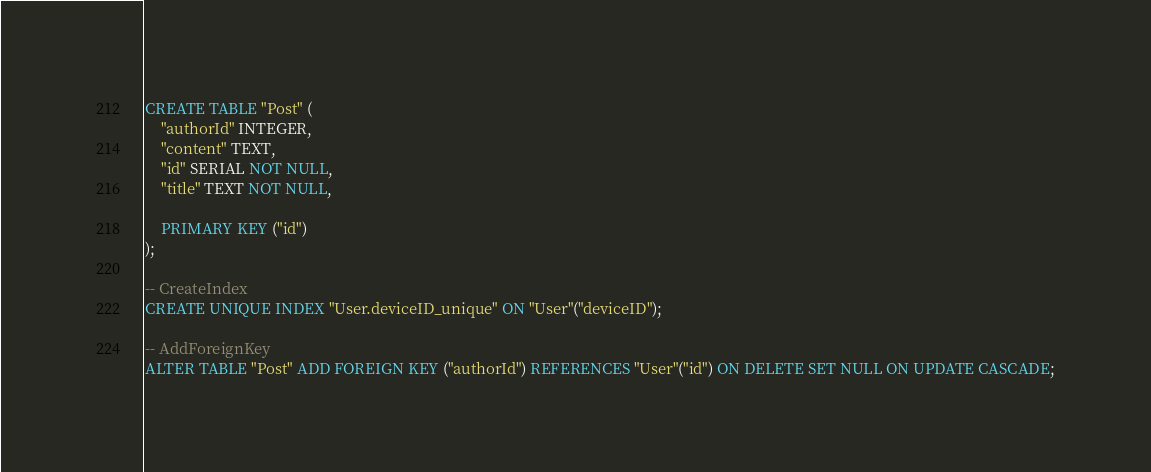<code> <loc_0><loc_0><loc_500><loc_500><_SQL_>CREATE TABLE "Post" (
    "authorId" INTEGER,
    "content" TEXT,
    "id" SERIAL NOT NULL,
    "title" TEXT NOT NULL,

    PRIMARY KEY ("id")
);

-- CreateIndex
CREATE UNIQUE INDEX "User.deviceID_unique" ON "User"("deviceID");

-- AddForeignKey
ALTER TABLE "Post" ADD FOREIGN KEY ("authorId") REFERENCES "User"("id") ON DELETE SET NULL ON UPDATE CASCADE;
</code> 